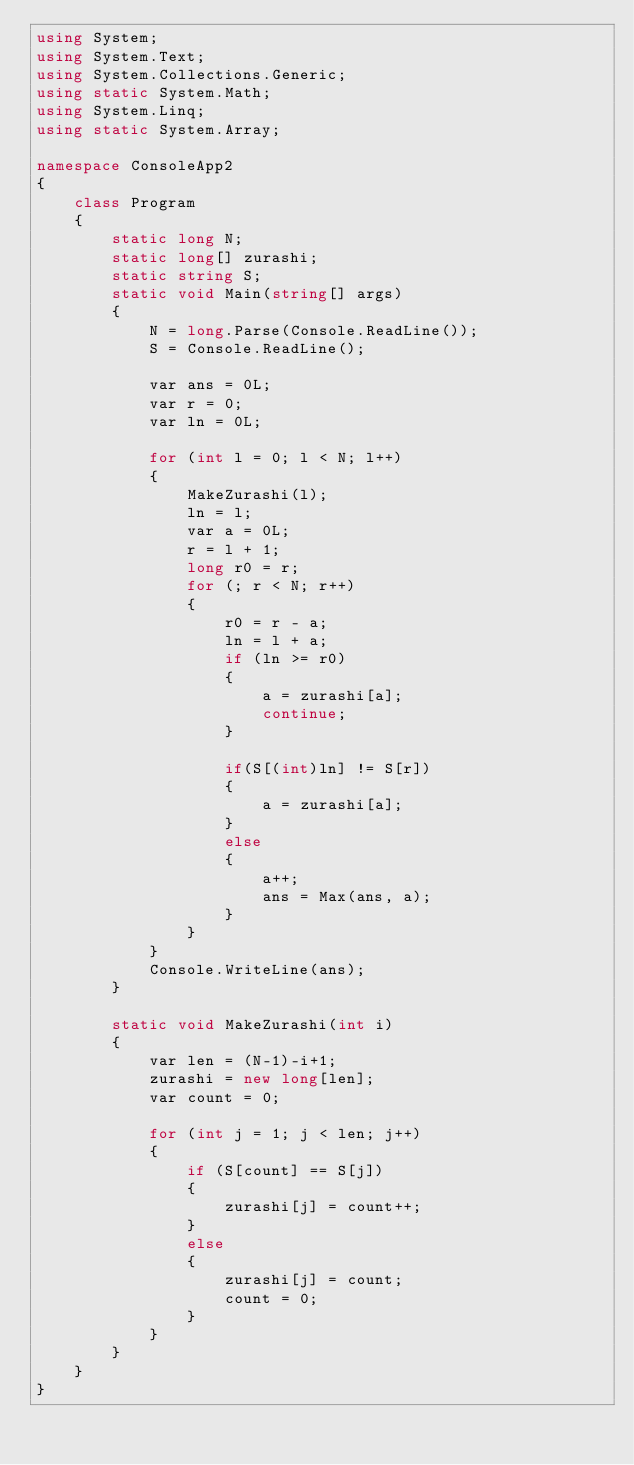<code> <loc_0><loc_0><loc_500><loc_500><_C#_>using System;
using System.Text;
using System.Collections.Generic;
using static System.Math;
using System.Linq;
using static System.Array;

namespace ConsoleApp2
{
    class Program
    {
        static long N;
        static long[] zurashi;
        static string S;
        static void Main(string[] args)
        {
            N = long.Parse(Console.ReadLine());
            S = Console.ReadLine();

            var ans = 0L;
            var r = 0;
            var ln = 0L;

            for (int l = 0; l < N; l++)
            {
                MakeZurashi(l);
                ln = l;
                var a = 0L;
                r = l + 1;
                long r0 = r;
                for (; r < N; r++)
                {
                    r0 = r - a;
                    ln = l + a;
                    if (ln >= r0)
                    {
                        a = zurashi[a];
                        continue;
                    }

                    if(S[(int)ln] != S[r])
                    {
                        a = zurashi[a];
                    }
                    else
                    {
                        a++;
                        ans = Max(ans, a);
                    }
                }
            }
            Console.WriteLine(ans);
        }

        static void MakeZurashi(int i)
        {
            var len = (N-1)-i+1;
            zurashi = new long[len];
            var count = 0;

            for (int j = 1; j < len; j++)
            {
                if (S[count] == S[j])
                {
                    zurashi[j] = count++;
                }
                else
                {
                    zurashi[j] = count;
                    count = 0;
                }
            }
        }
    }
}
</code> 